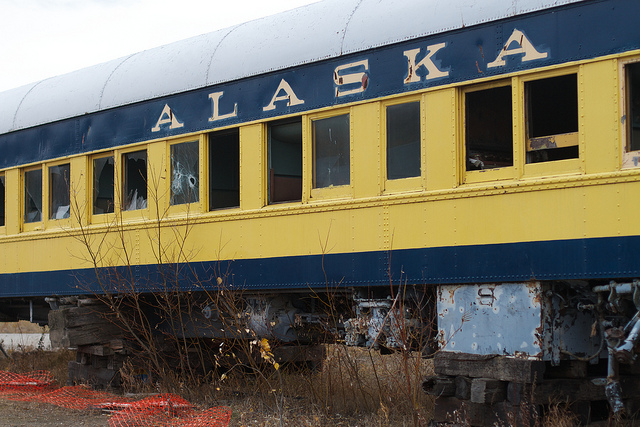Read all the text in this image. ALASKA B 